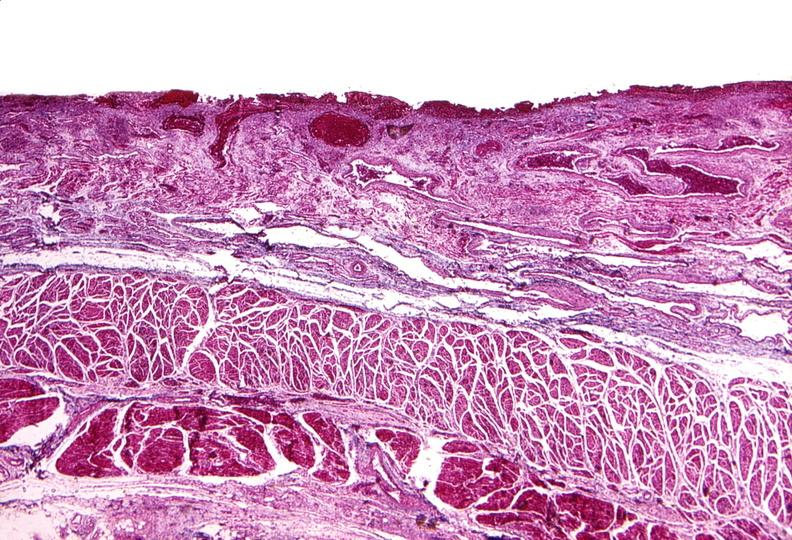what does this image show?
Answer the question using a single word or phrase. Esophagus 